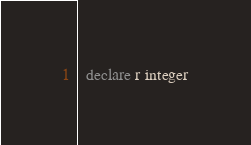Convert code to text. <code><loc_0><loc_0><loc_500><loc_500><_SQL_>  declare r integer
</code> 